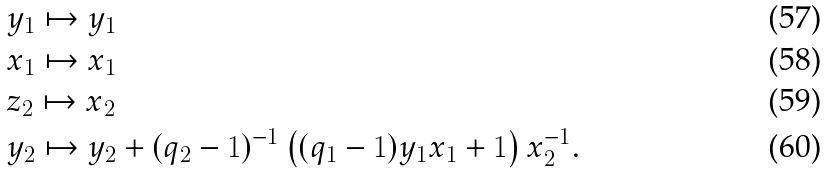<formula> <loc_0><loc_0><loc_500><loc_500>& y _ { 1 } \mapsto y _ { 1 } \\ & x _ { 1 } \mapsto x _ { 1 } \\ & z _ { 2 } \mapsto x _ { 2 } \\ & y _ { 2 } \mapsto y _ { 2 } + ( q _ { 2 } - 1 ) ^ { - 1 } \left ( ( q _ { 1 } - 1 ) y _ { 1 } x _ { 1 } + 1 \right ) x _ { 2 } ^ { - 1 } .</formula> 